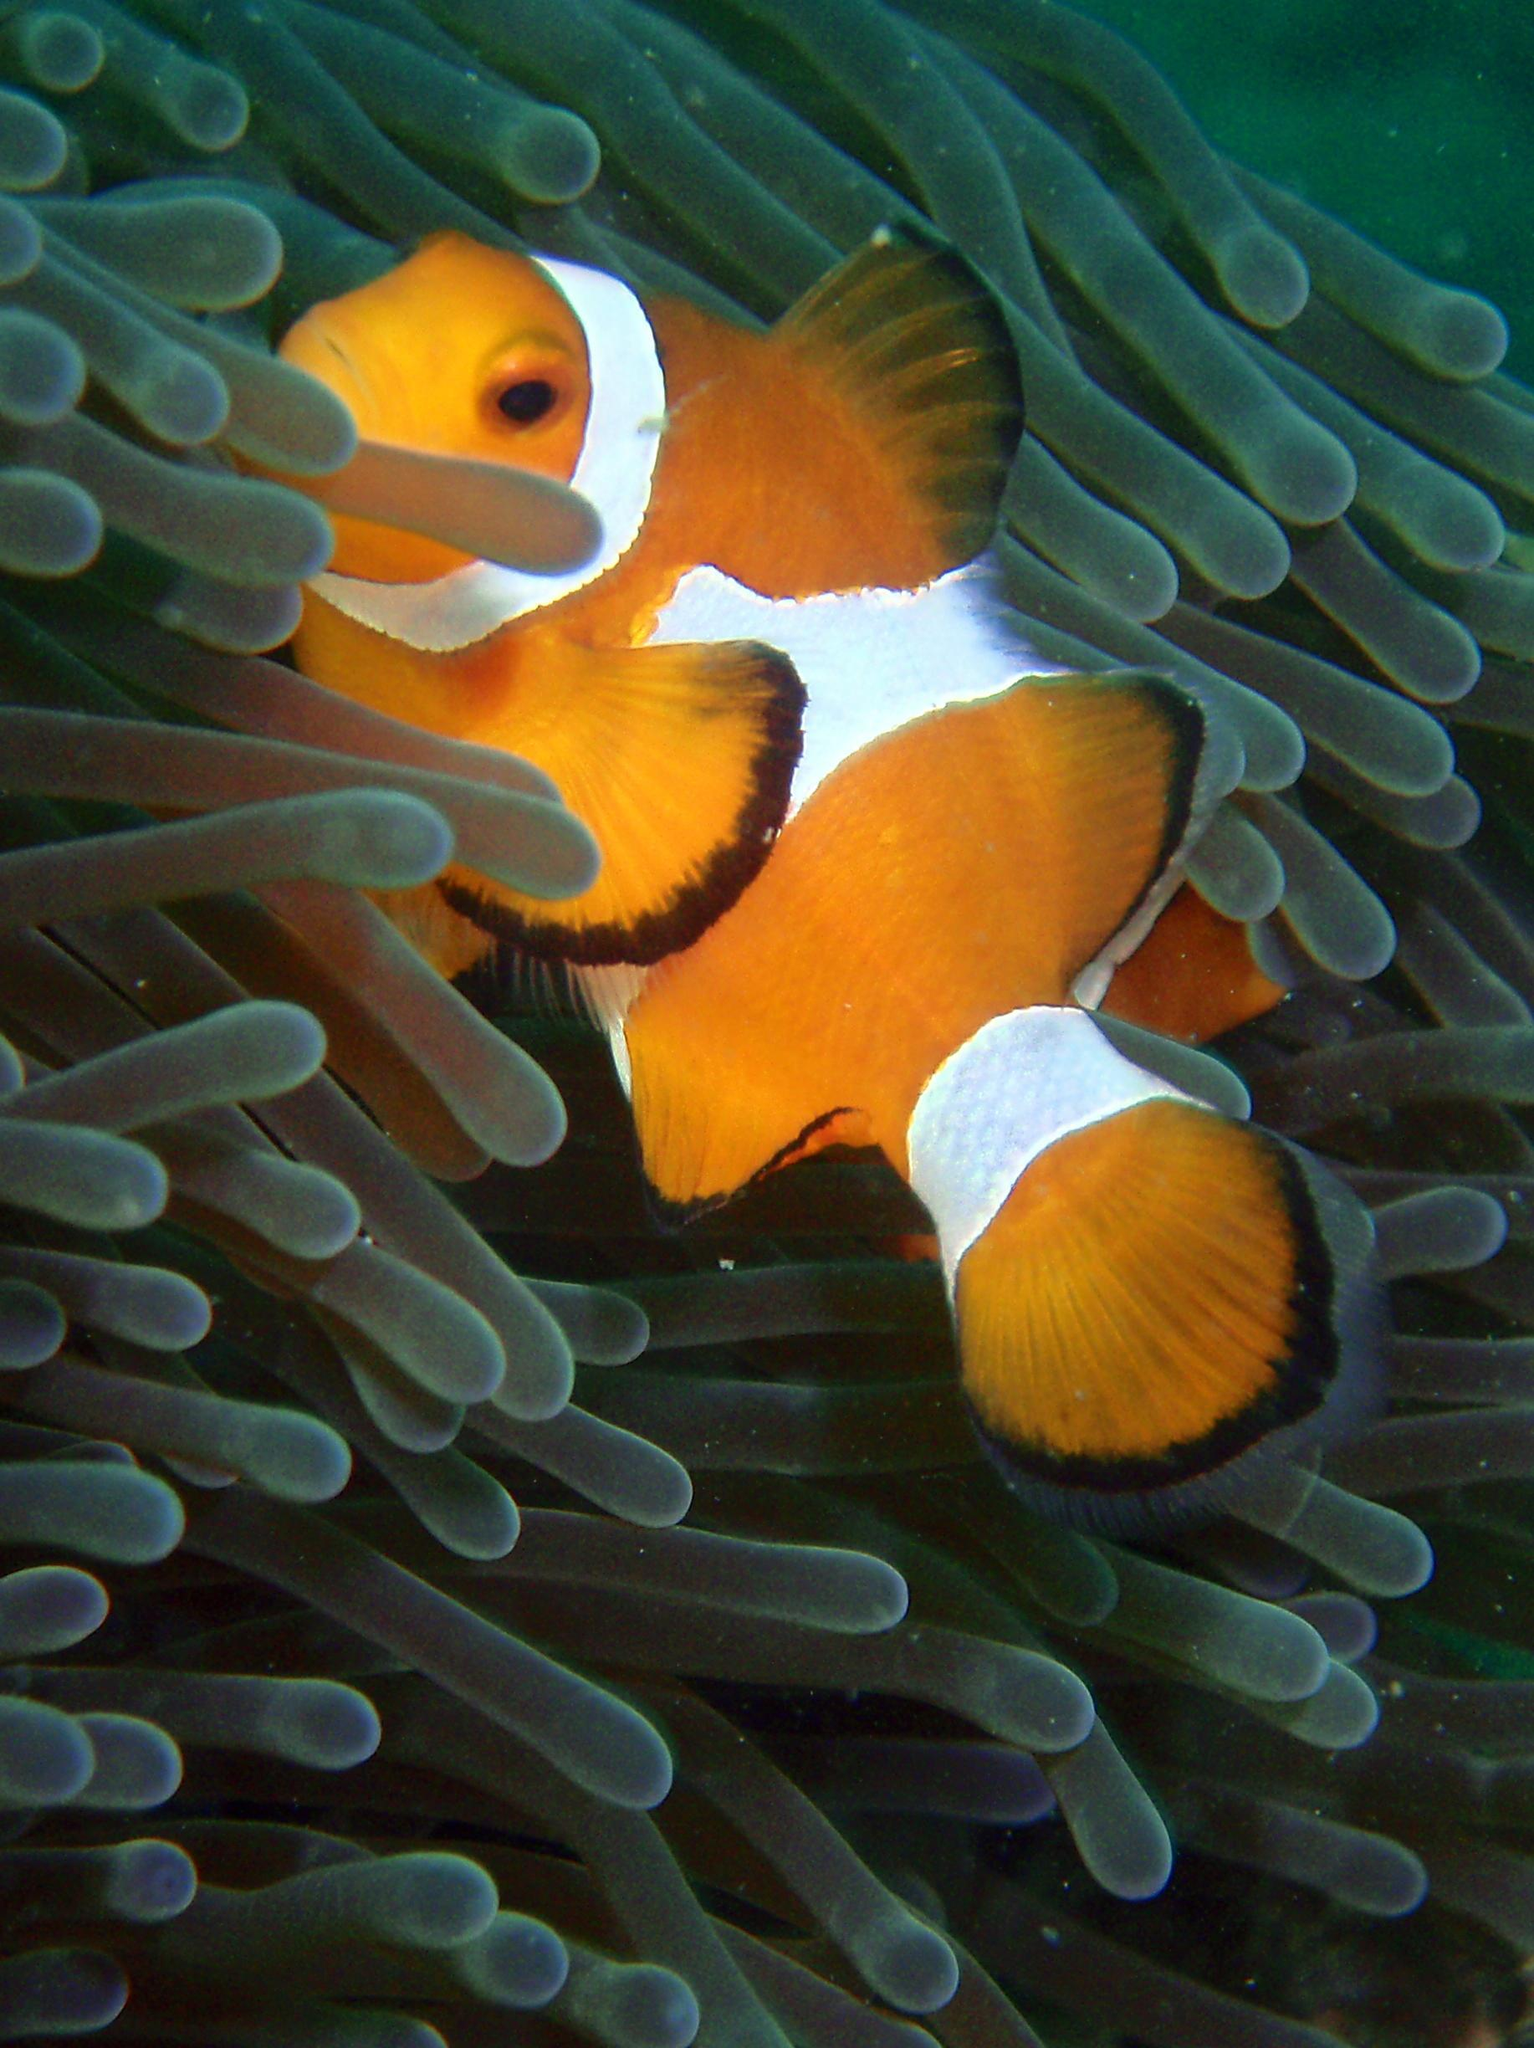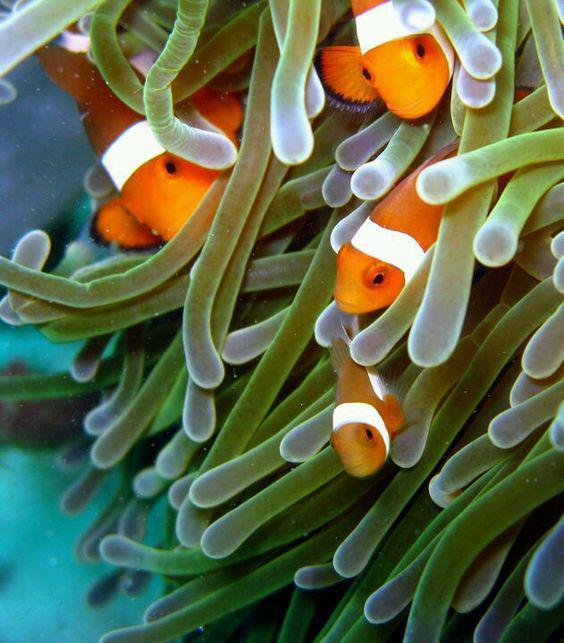The first image is the image on the left, the second image is the image on the right. Evaluate the accuracy of this statement regarding the images: "Each image shows clown fish swimming among anemone tendrils, but the right image contains at least twice as many clown fish.". Is it true? Answer yes or no. Yes. The first image is the image on the left, the second image is the image on the right. Analyze the images presented: Is the assertion "there are two orange and white colored fish swimming near an anemone" valid? Answer yes or no. No. 